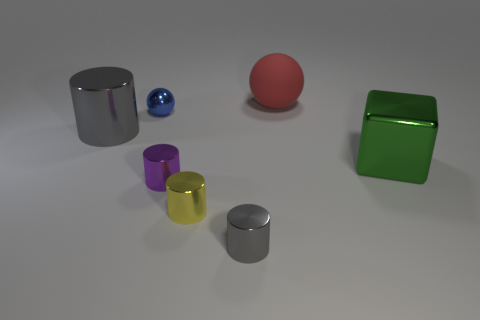Can you describe the shapes and colors of the objects placed in front of the green cube? In front of the green cube, you'll find a captivating array of shapes: a metallic gray cylinder with a sheen that catches the light, beside it, a smaller yet striking purple cylinder, and a bright, glossy yellow miniature cylinder. Each object is distinct not only in its vibrant hue but also in the way its surface interacts with the surrounding light. 